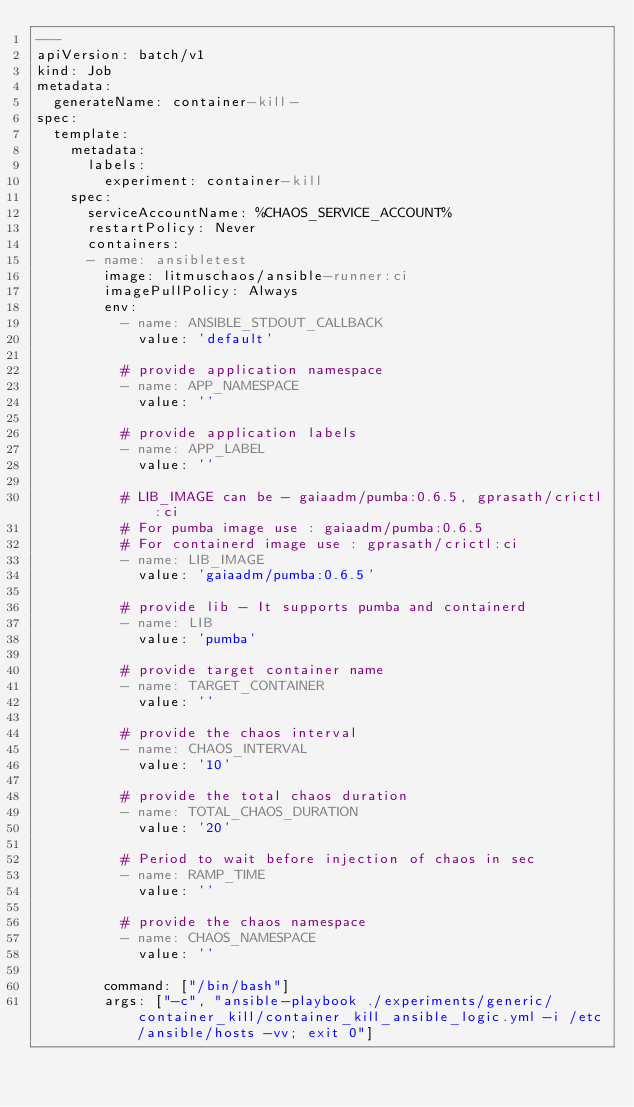<code> <loc_0><loc_0><loc_500><loc_500><_YAML_>---
apiVersion: batch/v1
kind: Job
metadata:
  generateName: container-kill-
spec:
  template:
    metadata:
      labels:
        experiment: container-kill
    spec:
      serviceAccountName: %CHAOS_SERVICE_ACCOUNT%
      restartPolicy: Never
      containers:
      - name: ansibletest
        image: litmuschaos/ansible-runner:ci
        imagePullPolicy: Always
        env:
          - name: ANSIBLE_STDOUT_CALLBACK
            value: 'default'
           
          # provide application namespace
          - name: APP_NAMESPACE 
            value: ''

          # provide application labels
          - name: APP_LABEL
            value: ''

          # LIB_IMAGE can be - gaiaadm/pumba:0.6.5, gprasath/crictl:ci
          # For pumba image use : gaiaadm/pumba:0.6.5
          # For containerd image use : gprasath/crictl:ci
          - name: LIB_IMAGE  
            value: 'gaiaadm/pumba:0.6.5'
            
          # provide lib - It supports pumba and containerd
          - name: LIB 
            value: 'pumba'

          # provide target container name
          - name: TARGET_CONTAINER
            value: ''

          # provide the chaos interval
          - name: CHAOS_INTERVAL
            value: '10'

          # provide the total chaos duration
          - name: TOTAL_CHAOS_DURATION
            value: '20'

          # Period to wait before injection of chaos in sec 
          - name: RAMP_TIME
            value: ''

          # provide the chaos namespace
          - name: CHAOS_NAMESPACE
            value: ''

        command: ["/bin/bash"]
        args: ["-c", "ansible-playbook ./experiments/generic/container_kill/container_kill_ansible_logic.yml -i /etc/ansible/hosts -vv; exit 0"]</code> 